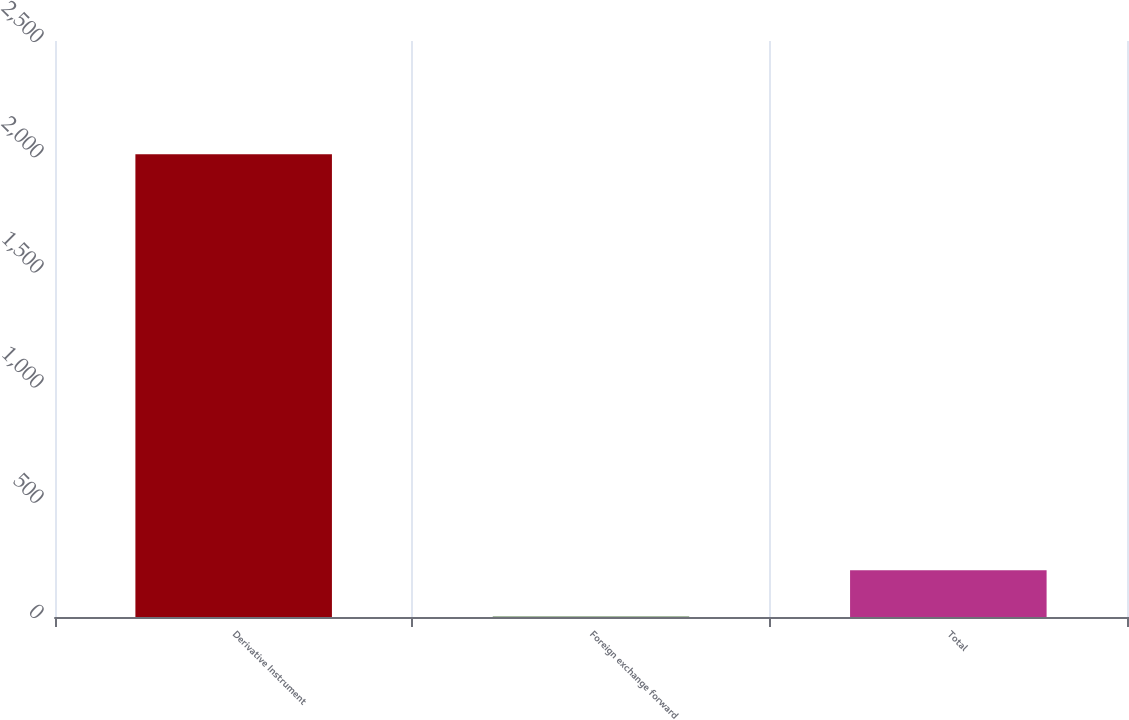Convert chart. <chart><loc_0><loc_0><loc_500><loc_500><bar_chart><fcel>Derivative Instrument<fcel>Foreign exchange forward<fcel>Total<nl><fcel>2008<fcel>2.2<fcel>202.78<nl></chart> 